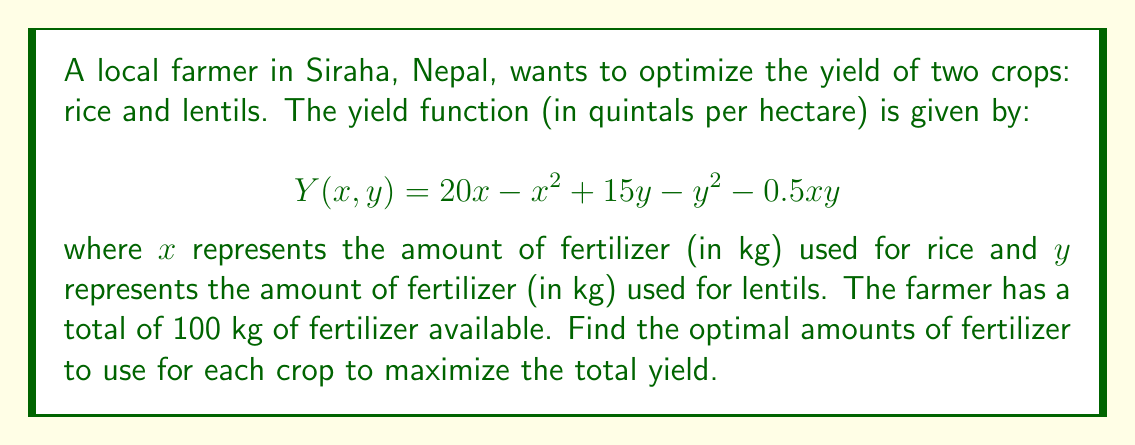What is the answer to this math problem? To solve this optimization problem, we'll use the method of Lagrange multipliers:

1) First, we set up the Lagrangian function:
   $$L(x, y, \lambda) = 20x - x^2 + 15y - y^2 - 0.5xy + \lambda(100 - x - y)$$

2) Now, we take partial derivatives and set them equal to zero:
   $$\frac{\partial L}{\partial x} = 20 - 2x - 0.5y - \lambda = 0$$
   $$\frac{\partial L}{\partial y} = 15 - 2y - 0.5x - \lambda = 0$$
   $$\frac{\partial L}{\partial \lambda} = 100 - x - y = 0$$

3) From the first two equations:
   $$20 - 2x - 0.5y = 15 - 2y - 0.5x$$
   $$5 - 1.5x = 1.5y$$
   $$y = \frac{5 - 1.5x}{1.5} = \frac{10 - 3x}{3}$$

4) Substitute this into the constraint equation:
   $$100 - x - \frac{10 - 3x}{3} = 0$$
   $$300 - 3x - 10 + 3x = 0$$
   $$290 = 0$$

   This is always false, so our solution is not on the interior of the constraint.

5) We need to check the boundary of the constraint. When $x + y = 100$, substitute $y = 100 - x$ into the original function:
   $$Y(x) = 20x - x^2 + 15(100-x) - (100-x)^2 - 0.5x(100-x)$$
   $$= 20x - x^2 + 1500 - 15x - 10000 + 200x - x^2 - 50x + 0.5x^2$$
   $$= -8500 + 155x - 1.5x^2$$

6) To find the maximum of this function, we differentiate and set to zero:
   $$\frac{dY}{dx} = 155 - 3x = 0$$
   $$x = \frac{155}{3} \approx 51.67$$

7) Therefore, $y = 100 - 51.67 = 48.33$

8) We should also check the endpoints $(0, 100)$ and $(100, 0)$, but these yield lower values.
Answer: $x \approx 51.67$ kg, $y \approx 48.33$ kg 